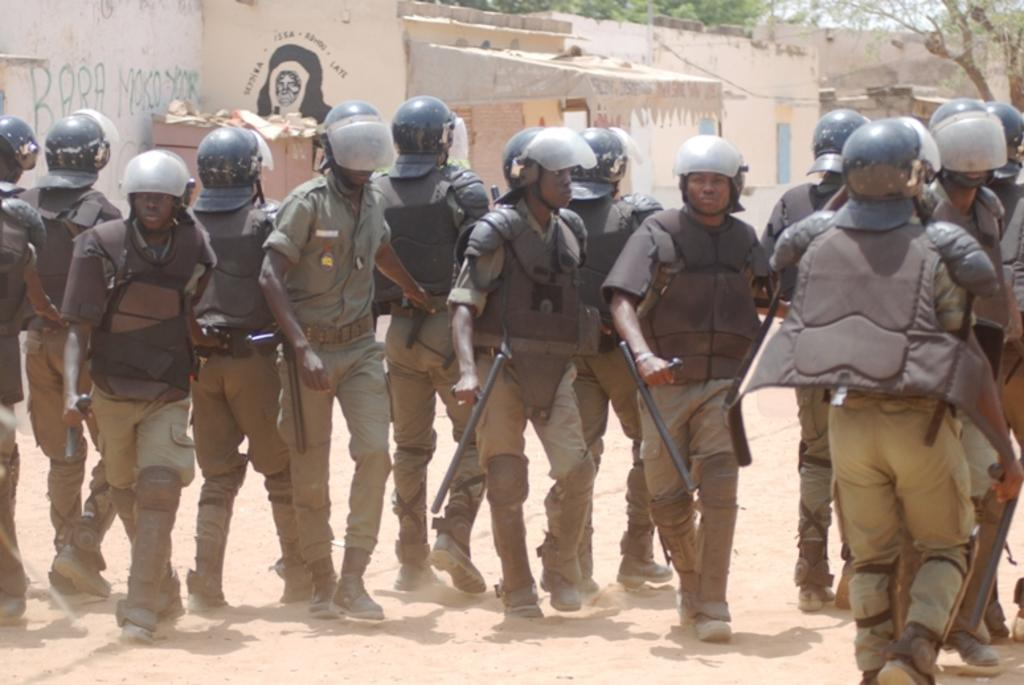What type of people can be seen in the image? There are cops in the image. What are the cops holding in their hands? The cops are holding guns. What can be seen in the distance behind the cops? There are buildings and trees in the background of the image. What is visible at the bottom of the image? There is ground visible at the bottom of the image. Where are the cherries located in the image? There are no cherries present in the image. What type of box can be seen in the image? There is no box present in the image. 